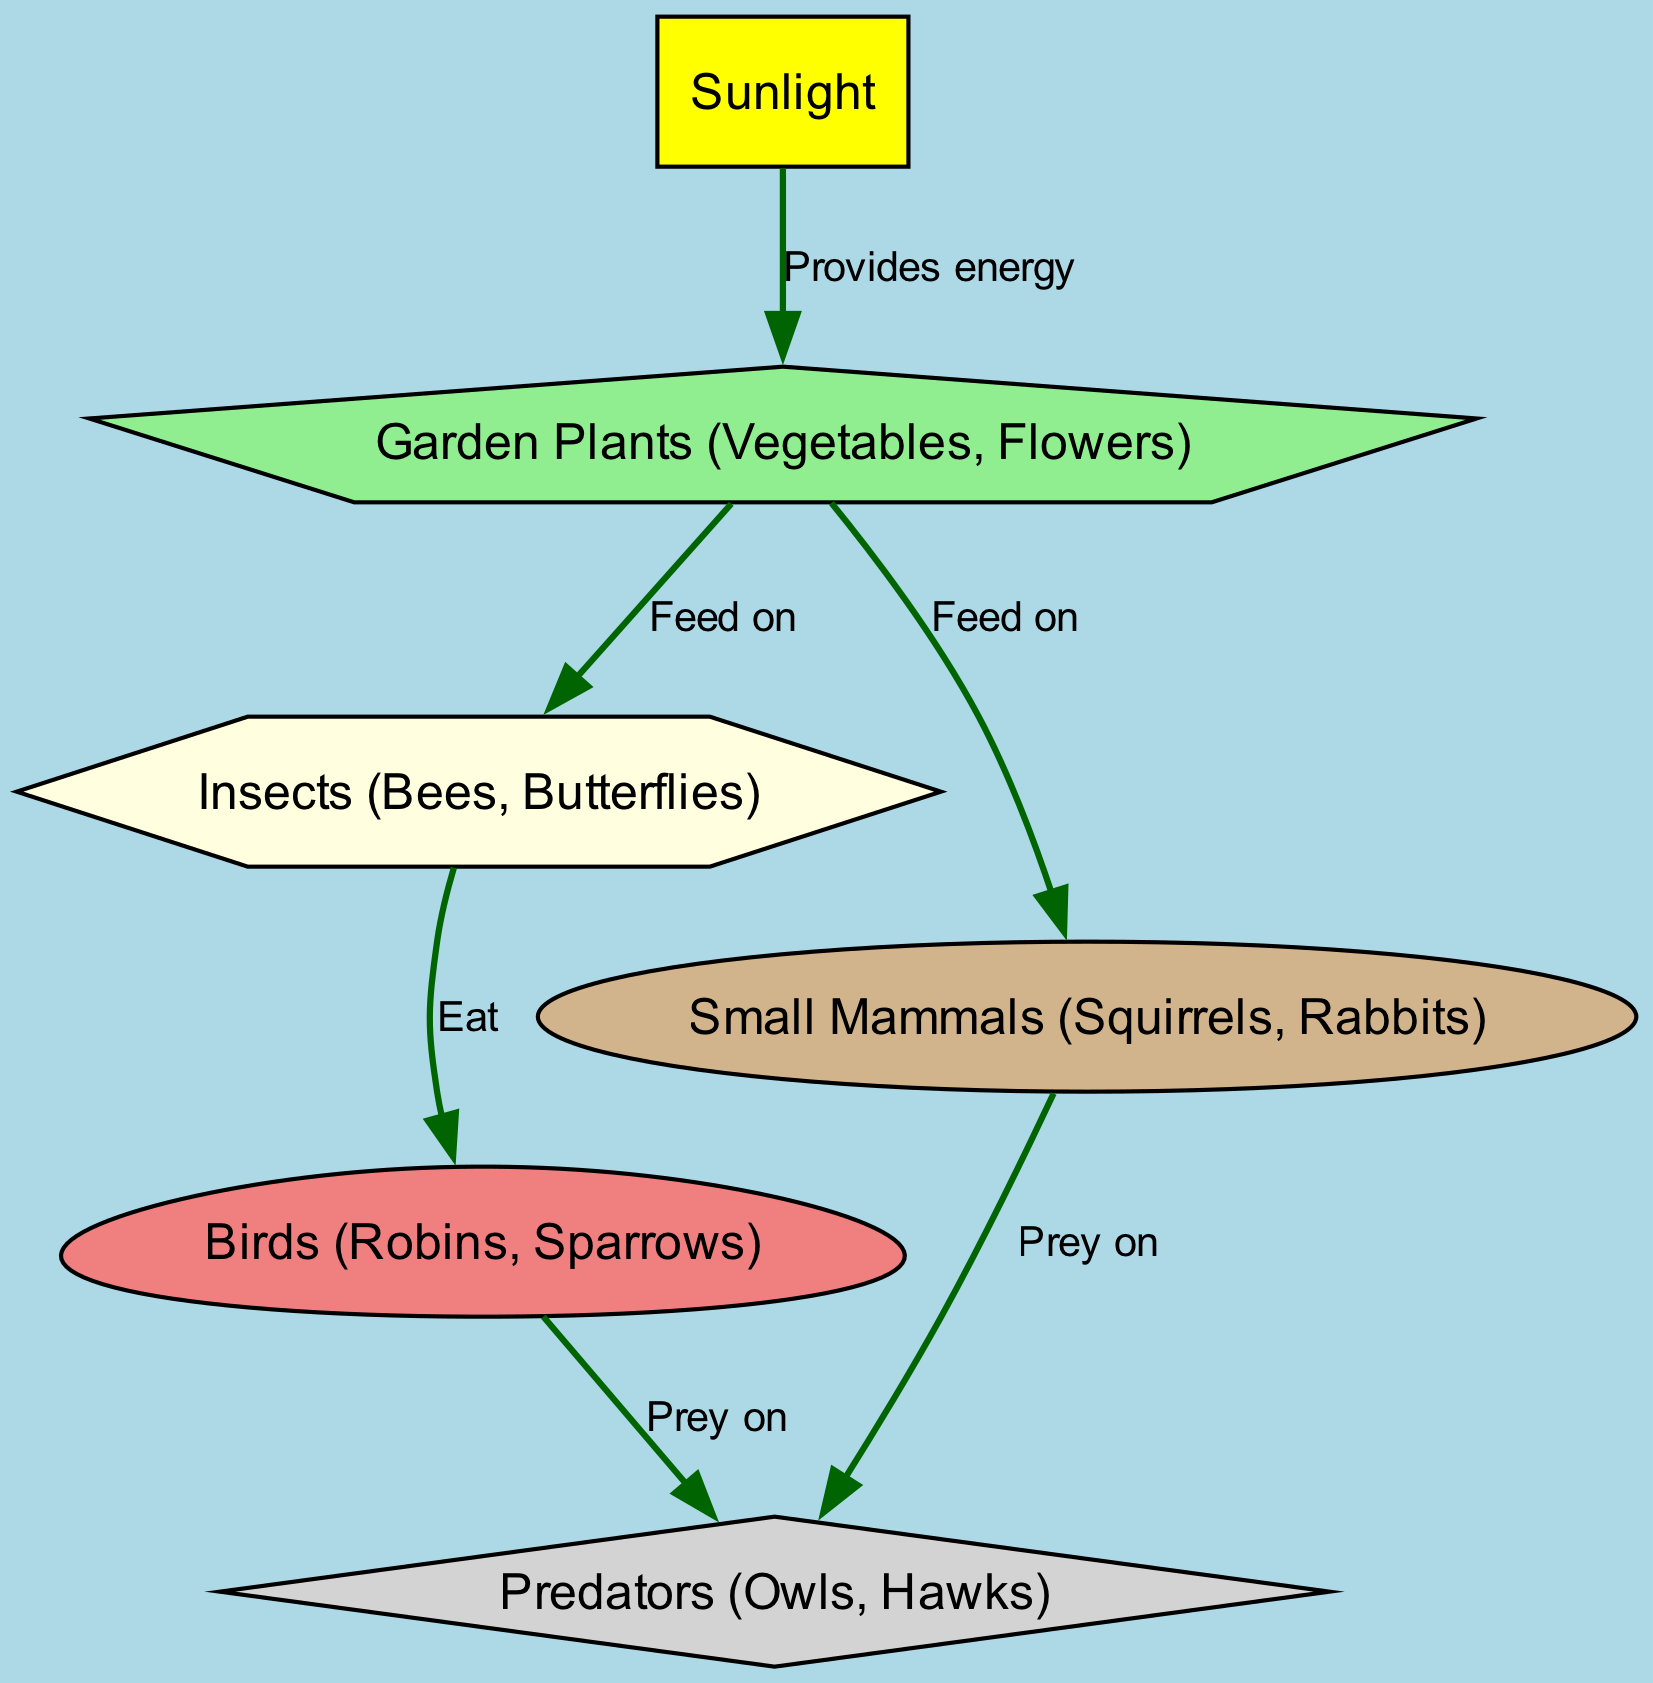What is the first element in the food chain? The first element in the food chain is "Sunlight," as it provides energy to the garden plants.
Answer: Sunlight How many different types of animals are shown in the diagram? The types of animals depicted are insects, birds, small mammals, and predators. This totals to four types of animals.
Answer: Four What do garden plants provide for insects? Garden plants provide food for insects, which is indicated by the relationship labeled "Feed on."
Answer: Food Which type of animal preys on both birds and small mammals? The type of animal that preys on both birds and small mammals is "Predators," as shown in the edges leading from both animals to predators.
Answer: Predators How many connections are there from garden plants to other elements? Garden plants are connected to insects and small mammals, making a total of two connections.
Answer: Two What do insects eat? Insects eat garden plants, as indicated in the diagram.
Answer: Garden plants Which element is the final predator in the food chain? The final predator in the food chain is "Predators," as they are at the top of the food chain depicted in the diagram.
Answer: Predators What provides energy to the garden plants? "Sunlight" provides energy to the garden plants, as shown in the relationship labeled "Provides energy."
Answer: Sunlight Which two elements are linked to the predators? The two elements linked to the predators are "Birds" and "Small Mammals," both showing a relationship labeled "Prey on."
Answer: Birds and Small Mammals 